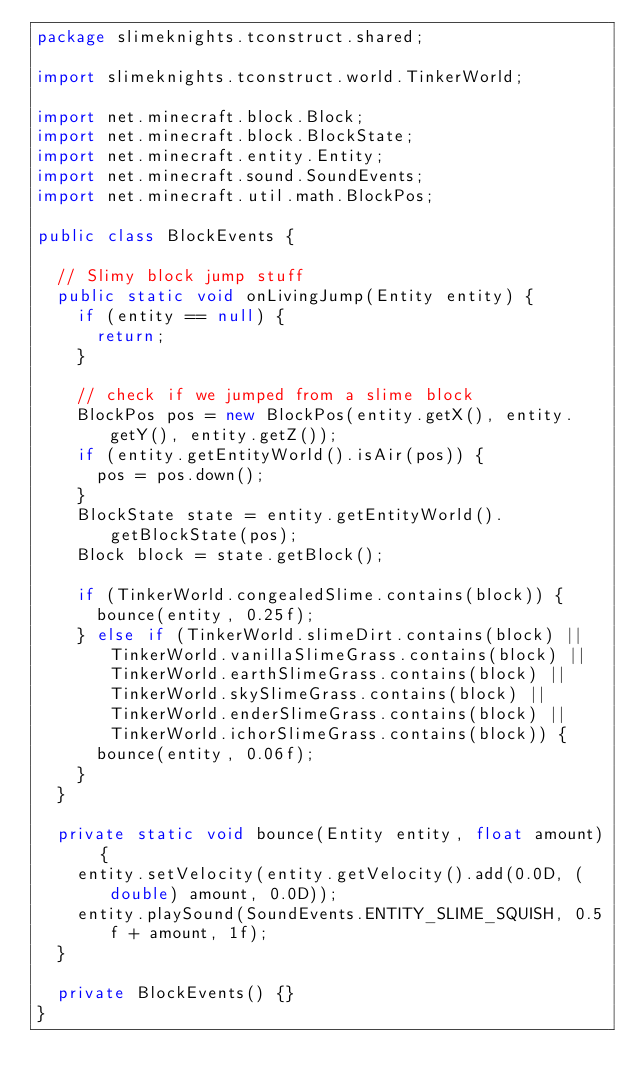<code> <loc_0><loc_0><loc_500><loc_500><_Java_>package slimeknights.tconstruct.shared;

import slimeknights.tconstruct.world.TinkerWorld;

import net.minecraft.block.Block;
import net.minecraft.block.BlockState;
import net.minecraft.entity.Entity;
import net.minecraft.sound.SoundEvents;
import net.minecraft.util.math.BlockPos;

public class BlockEvents {

  // Slimy block jump stuff
  public static void onLivingJump(Entity entity) {
    if (entity == null) {
      return;
    }

    // check if we jumped from a slime block
    BlockPos pos = new BlockPos(entity.getX(), entity.getY(), entity.getZ());
    if (entity.getEntityWorld().isAir(pos)) {
      pos = pos.down();
    }
    BlockState state = entity.getEntityWorld().getBlockState(pos);
    Block block = state.getBlock();

    if (TinkerWorld.congealedSlime.contains(block)) {
      bounce(entity, 0.25f);
    } else if (TinkerWorld.slimeDirt.contains(block) || TinkerWorld.vanillaSlimeGrass.contains(block) || TinkerWorld.earthSlimeGrass.contains(block) || TinkerWorld.skySlimeGrass.contains(block) || TinkerWorld.enderSlimeGrass.contains(block) || TinkerWorld.ichorSlimeGrass.contains(block)) {
      bounce(entity, 0.06f);
    }
  }

  private static void bounce(Entity entity, float amount) {
    entity.setVelocity(entity.getVelocity().add(0.0D, (double) amount, 0.0D));
    entity.playSound(SoundEvents.ENTITY_SLIME_SQUISH, 0.5f + amount, 1f);
  }

  private BlockEvents() {}
}
</code> 